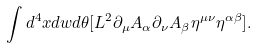Convert formula to latex. <formula><loc_0><loc_0><loc_500><loc_500>\int d ^ { 4 } x d w d \theta [ L ^ { 2 } \partial _ { \mu } A _ { \alpha } \partial _ { \nu } A _ { \beta } \eta ^ { \mu \nu } \eta ^ { \alpha \beta } ] .</formula> 